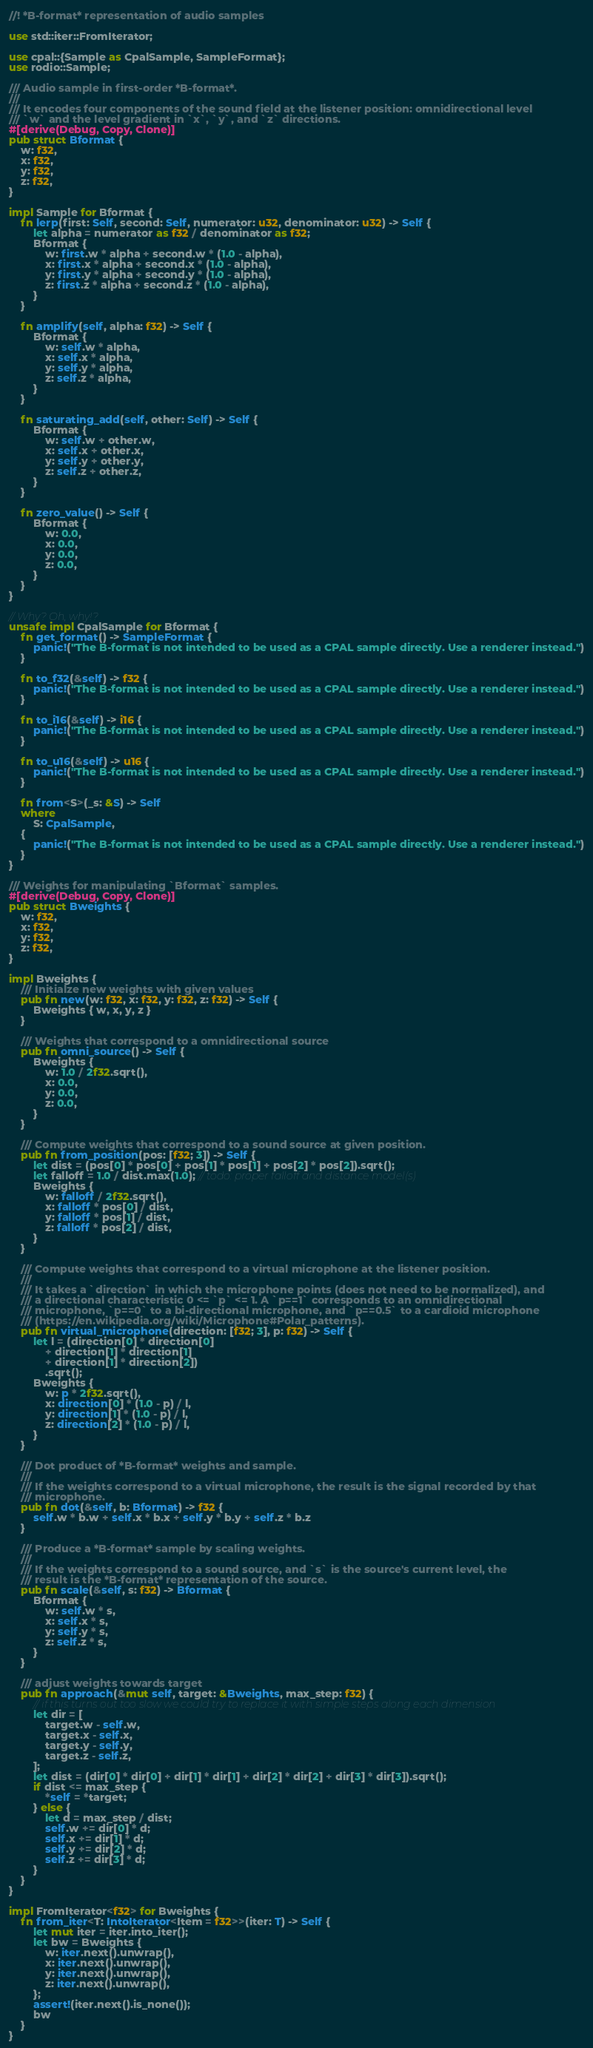Convert code to text. <code><loc_0><loc_0><loc_500><loc_500><_Rust_>//! *B-format* representation of audio samples

use std::iter::FromIterator;

use cpal::{Sample as CpalSample, SampleFormat};
use rodio::Sample;

/// Audio sample in first-order *B-format*.
///
/// It encodes four components of the sound field at the listener position: omnidirectional level
/// `w` and the level gradient in `x`, `y`, and `z` directions.
#[derive(Debug, Copy, Clone)]
pub struct Bformat {
    w: f32,
    x: f32,
    y: f32,
    z: f32,
}

impl Sample for Bformat {
    fn lerp(first: Self, second: Self, numerator: u32, denominator: u32) -> Self {
        let alpha = numerator as f32 / denominator as f32;
        Bformat {
            w: first.w * alpha + second.w * (1.0 - alpha),
            x: first.x * alpha + second.x * (1.0 - alpha),
            y: first.y * alpha + second.y * (1.0 - alpha),
            z: first.z * alpha + second.z * (1.0 - alpha),
        }
    }

    fn amplify(self, alpha: f32) -> Self {
        Bformat {
            w: self.w * alpha,
            x: self.x * alpha,
            y: self.y * alpha,
            z: self.z * alpha,
        }
    }

    fn saturating_add(self, other: Self) -> Self {
        Bformat {
            w: self.w + other.w,
            x: self.x + other.x,
            y: self.y + other.y,
            z: self.z + other.z,
        }
    }

    fn zero_value() -> Self {
        Bformat {
            w: 0.0,
            x: 0.0,
            y: 0.0,
            z: 0.0,
        }
    }
}

// Why? Oh, why!?
unsafe impl CpalSample for Bformat {
    fn get_format() -> SampleFormat {
        panic!("The B-format is not intended to be used as a CPAL sample directly. Use a renderer instead.")
    }

    fn to_f32(&self) -> f32 {
        panic!("The B-format is not intended to be used as a CPAL sample directly. Use a renderer instead.")
    }

    fn to_i16(&self) -> i16 {
        panic!("The B-format is not intended to be used as a CPAL sample directly. Use a renderer instead.")
    }

    fn to_u16(&self) -> u16 {
        panic!("The B-format is not intended to be used as a CPAL sample directly. Use a renderer instead.")
    }

    fn from<S>(_s: &S) -> Self
    where
        S: CpalSample,
    {
        panic!("The B-format is not intended to be used as a CPAL sample directly. Use a renderer instead.")
    }
}

/// Weights for manipulating `Bformat` samples.
#[derive(Debug, Copy, Clone)]
pub struct Bweights {
    w: f32,
    x: f32,
    y: f32,
    z: f32,
}

impl Bweights {
    /// Initialze new weights with given values
    pub fn new(w: f32, x: f32, y: f32, z: f32) -> Self {
        Bweights { w, x, y, z }
    }

    /// Weights that correspond to a omnidirectional source
    pub fn omni_source() -> Self {
        Bweights {
            w: 1.0 / 2f32.sqrt(),
            x: 0.0,
            y: 0.0,
            z: 0.0,
        }
    }

    /// Compute weights that correspond to a sound source at given position.
    pub fn from_position(pos: [f32; 3]) -> Self {
        let dist = (pos[0] * pos[0] + pos[1] * pos[1] + pos[2] * pos[2]).sqrt();
        let falloff = 1.0 / dist.max(1.0); // todo: proper falloff and distance model(s)
        Bweights {
            w: falloff / 2f32.sqrt(),
            x: falloff * pos[0] / dist,
            y: falloff * pos[1] / dist,
            z: falloff * pos[2] / dist,
        }
    }

    /// Compute weights that correspond to a virtual microphone at the listener position.
    ///
    /// It takes a `direction` in which the microphone points (does not need to be normalized), and
    /// a directional characteristic 0 <= `p` <= 1. A `p==1` corresponds to an omnidirectional
    /// microphone, `p==0` to a bi-directional microphone, and `p==0.5` to a cardioid microphone
    /// (https://en.wikipedia.org/wiki/Microphone#Polar_patterns).
    pub fn virtual_microphone(direction: [f32; 3], p: f32) -> Self {
        let l = (direction[0] * direction[0]
            + direction[1] * direction[1]
            + direction[1] * direction[2])
            .sqrt();
        Bweights {
            w: p * 2f32.sqrt(),
            x: direction[0] * (1.0 - p) / l,
            y: direction[1] * (1.0 - p) / l,
            z: direction[2] * (1.0 - p) / l,
        }
    }

    /// Dot product of *B-format* weights and sample.
    ///
    /// If the weights correspond to a virtual microphone, the result is the signal recorded by that
    /// microphone.
    pub fn dot(&self, b: Bformat) -> f32 {
        self.w * b.w + self.x * b.x + self.y * b.y + self.z * b.z
    }

    /// Produce a *B-format* sample by scaling weights.
    ///
    /// If the weights correspond to a sound source, and `s` is the source's current level, the
    /// result is the *B-format* representation of the source.
    pub fn scale(&self, s: f32) -> Bformat {
        Bformat {
            w: self.w * s,
            x: self.x * s,
            y: self.y * s,
            z: self.z * s,
        }
    }

    /// adjust weights towards target
    pub fn approach(&mut self, target: &Bweights, max_step: f32) {
        // if this turns out too slow we could try to replace it with simple steps along each dimension
        let dir = [
            target.w - self.w,
            target.x - self.x,
            target.y - self.y,
            target.z - self.z,
        ];
        let dist = (dir[0] * dir[0] + dir[1] * dir[1] + dir[2] * dir[2] + dir[3] * dir[3]).sqrt();
        if dist <= max_step {
            *self = *target;
        } else {
            let d = max_step / dist;
            self.w += dir[0] * d;
            self.x += dir[1] * d;
            self.y += dir[2] * d;
            self.z += dir[3] * d;
        }
    }
}

impl FromIterator<f32> for Bweights {
    fn from_iter<T: IntoIterator<Item = f32>>(iter: T) -> Self {
        let mut iter = iter.into_iter();
        let bw = Bweights {
            w: iter.next().unwrap(),
            x: iter.next().unwrap(),
            y: iter.next().unwrap(),
            z: iter.next().unwrap(),
        };
        assert!(iter.next().is_none());
        bw
    }
}
</code> 